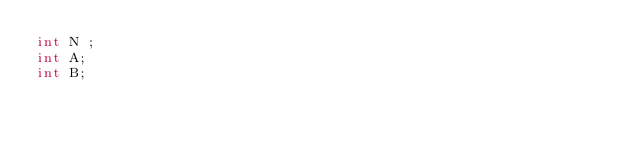<code> <loc_0><loc_0><loc_500><loc_500><_C#_>int N ;
int A;
int B;</code> 